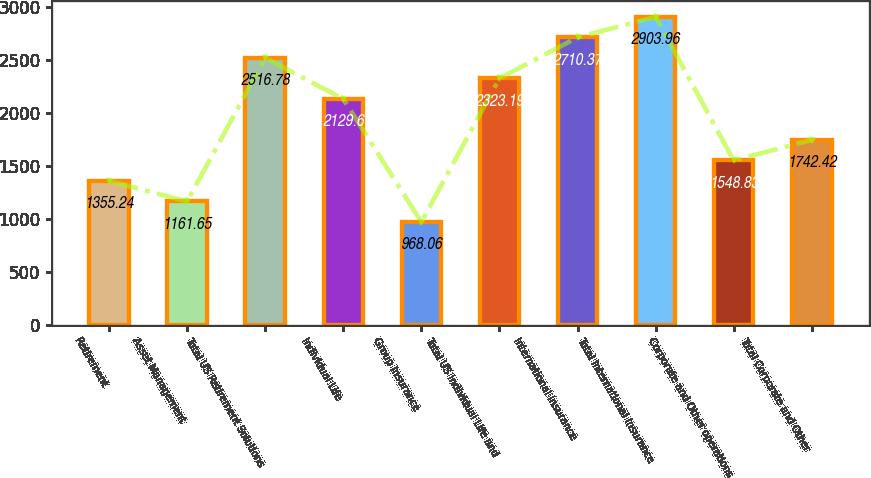Convert chart. <chart><loc_0><loc_0><loc_500><loc_500><bar_chart><fcel>Retirement<fcel>Asset Management<fcel>Total US Retirement Solutions<fcel>Individual Life<fcel>Group Insurance<fcel>Total US Individual Life and<fcel>International Insurance<fcel>Total International Insurance<fcel>Corporate and Other operations<fcel>Total Corporate and Other<nl><fcel>1355.24<fcel>1161.65<fcel>2516.78<fcel>2129.6<fcel>968.06<fcel>2323.19<fcel>2710.37<fcel>2903.96<fcel>1548.83<fcel>1742.42<nl></chart> 